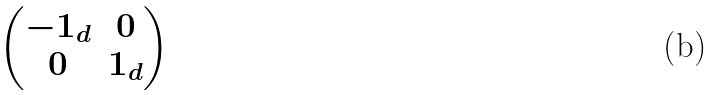Convert formula to latex. <formula><loc_0><loc_0><loc_500><loc_500>\begin{pmatrix} - { 1 } _ { d } & 0 \\ 0 & { 1 } _ { d } \end{pmatrix}</formula> 